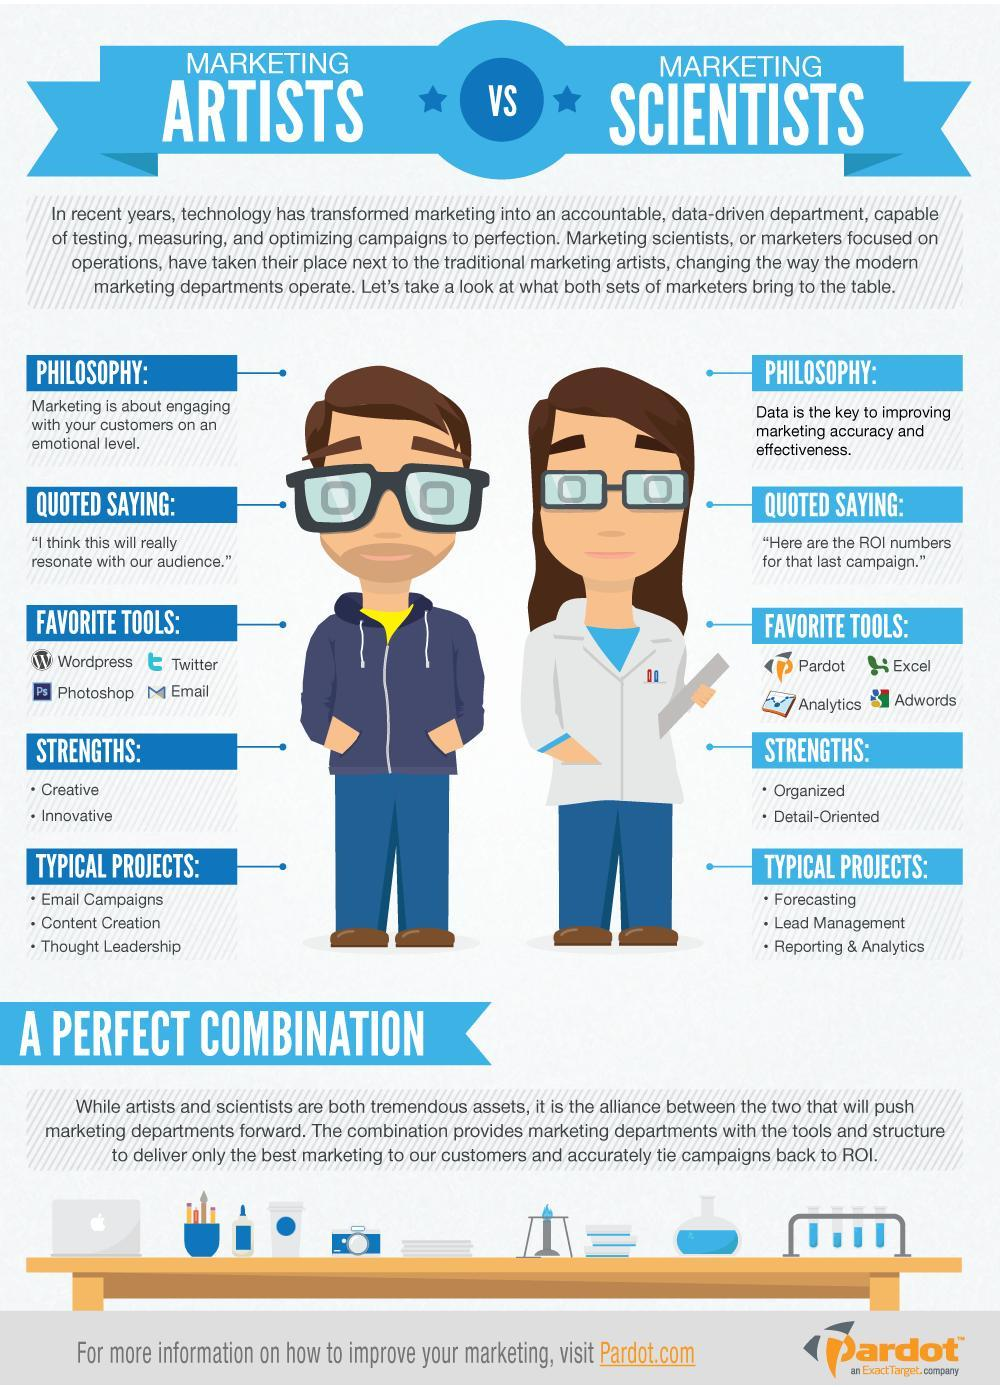How many favorite tools for Marketing Artists?
Answer the question with a short phrase. 4 What are the strengths of Marketing Scientists? Organized, Detail-Oriented What are the typical projects of Marketing Scientists? Forecasting, Lead Management, Reporting & Analytics How many favorite tools for Marketing Scientists? 4 What are the strengths of Marketing Artists? Creative, Innovative What are the typical projects of Marketing Artists? Email Campaigns, Content Creation, Thought Leadership 